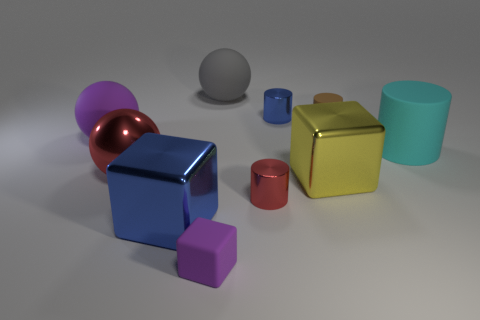Subtract all blue cylinders. How many cylinders are left? 3 Subtract all small cylinders. How many cylinders are left? 1 Subtract 1 spheres. How many spheres are left? 2 Subtract all cylinders. How many objects are left? 6 Subtract all gray cylinders. Subtract all gray blocks. How many cylinders are left? 4 Subtract all big cyan rubber cylinders. Subtract all gray rubber things. How many objects are left? 8 Add 4 small blue cylinders. How many small blue cylinders are left? 5 Add 9 small purple blocks. How many small purple blocks exist? 10 Subtract 0 gray cubes. How many objects are left? 10 